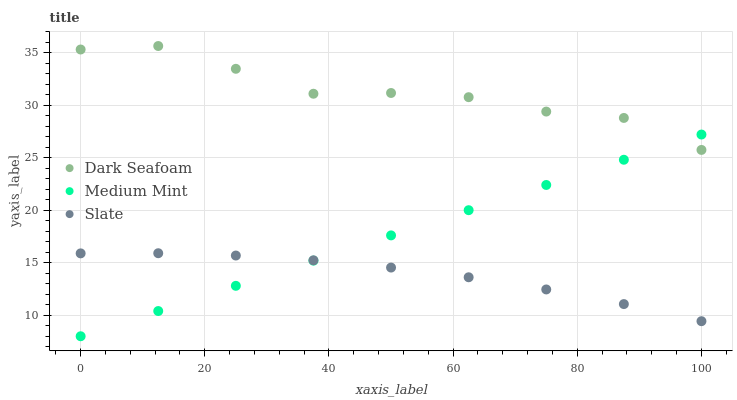Does Slate have the minimum area under the curve?
Answer yes or no. Yes. Does Dark Seafoam have the maximum area under the curve?
Answer yes or no. Yes. Does Dark Seafoam have the minimum area under the curve?
Answer yes or no. No. Does Slate have the maximum area under the curve?
Answer yes or no. No. Is Medium Mint the smoothest?
Answer yes or no. Yes. Is Dark Seafoam the roughest?
Answer yes or no. Yes. Is Slate the smoothest?
Answer yes or no. No. Is Slate the roughest?
Answer yes or no. No. Does Medium Mint have the lowest value?
Answer yes or no. Yes. Does Slate have the lowest value?
Answer yes or no. No. Does Dark Seafoam have the highest value?
Answer yes or no. Yes. Does Slate have the highest value?
Answer yes or no. No. Is Slate less than Dark Seafoam?
Answer yes or no. Yes. Is Dark Seafoam greater than Slate?
Answer yes or no. Yes. Does Slate intersect Medium Mint?
Answer yes or no. Yes. Is Slate less than Medium Mint?
Answer yes or no. No. Is Slate greater than Medium Mint?
Answer yes or no. No. Does Slate intersect Dark Seafoam?
Answer yes or no. No. 